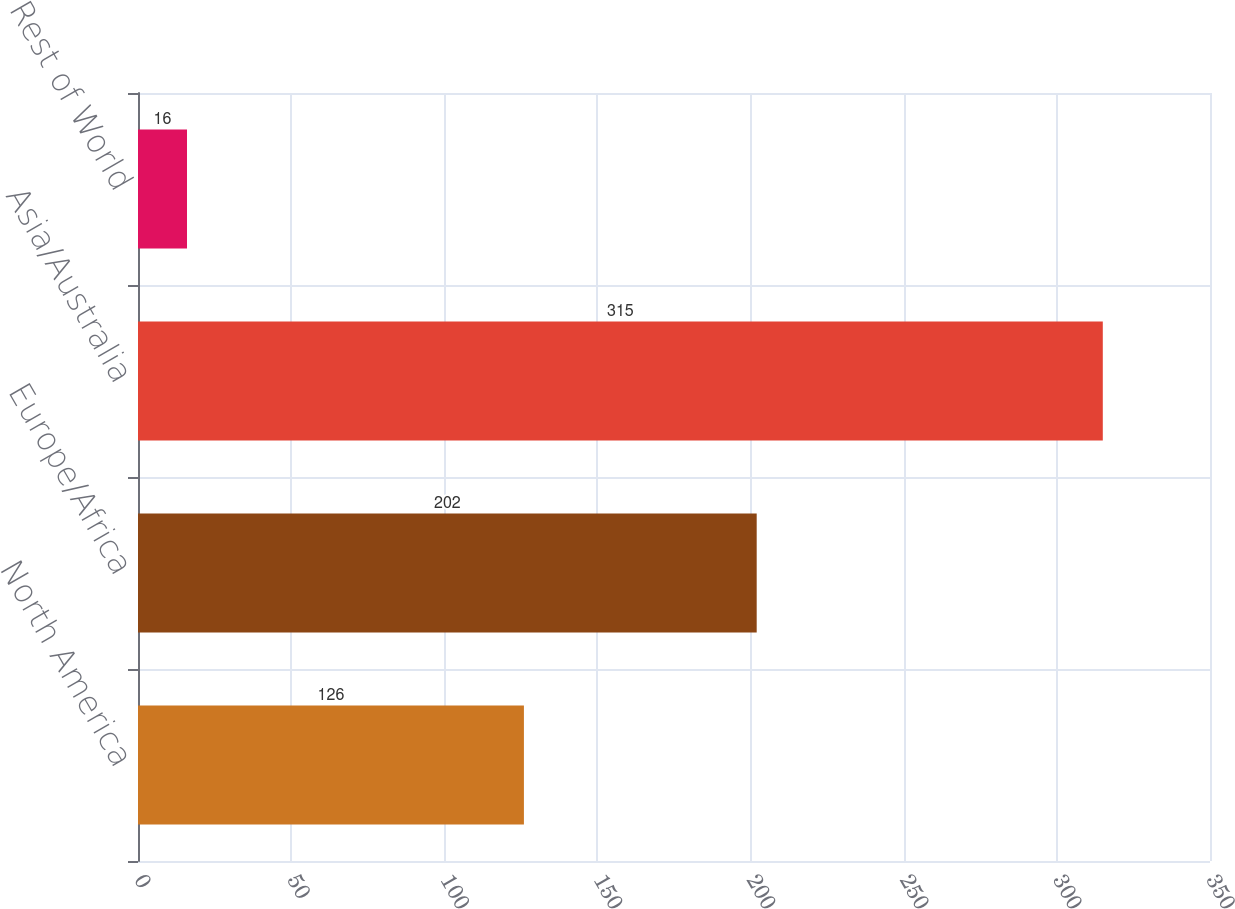<chart> <loc_0><loc_0><loc_500><loc_500><bar_chart><fcel>North America<fcel>Europe/Africa<fcel>Asia/Australia<fcel>Rest of World<nl><fcel>126<fcel>202<fcel>315<fcel>16<nl></chart> 